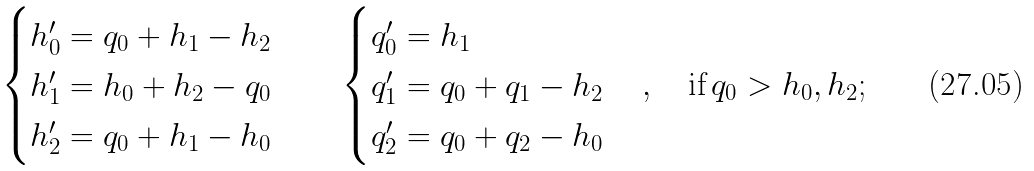Convert formula to latex. <formula><loc_0><loc_0><loc_500><loc_500>\begin{cases} h _ { 0 } ^ { \prime } = q _ { 0 } + h _ { 1 } - h _ { 2 } \\ h _ { 1 } ^ { \prime } = h _ { 0 } + h _ { 2 } - q _ { 0 } \\ h _ { 2 } ^ { \prime } = q _ { 0 } + h _ { 1 } - h _ { 0 } \end{cases} \quad \begin{cases} q _ { 0 } ^ { \prime } = h _ { 1 } \\ q _ { 1 } ^ { \prime } = q _ { 0 } + q _ { 1 } - h _ { 2 } \\ q _ { 2 } ^ { \prime } = q _ { 0 } + q _ { 2 } - h _ { 0 } \end{cases} , \quad \text {if} \, q _ { 0 } > h _ { 0 } , h _ { 2 } ;</formula> 